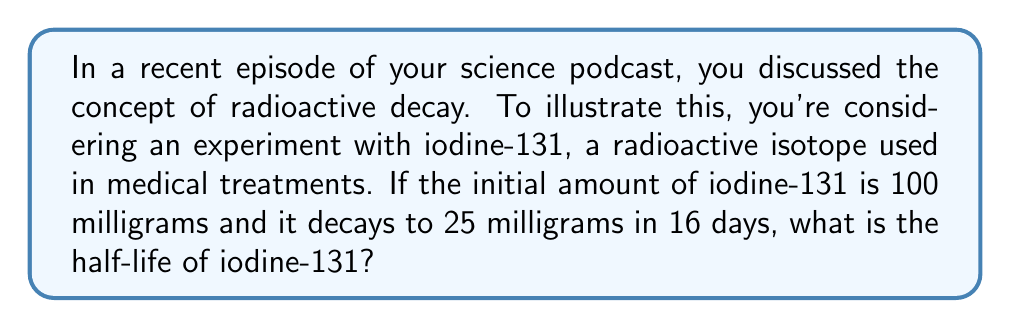Can you answer this question? Let's approach this step-by-step using the exponential decay formula:

1) The general form of the exponential decay equation is:
   $$ A(t) = A_0 e^{-\lambda t} $$
   where $A(t)$ is the amount at time $t$, $A_0$ is the initial amount, $\lambda$ is the decay constant, and $t$ is time.

2) We know:
   $A_0 = 100$ mg
   $A(16) = 25$ mg
   $t = 16$ days

3) Substituting these values into the equation:
   $$ 25 = 100 e^{-16\lambda} $$

4) Dividing both sides by 100:
   $$ 0.25 = e^{-16\lambda} $$

5) Taking the natural log of both sides:
   $$ \ln(0.25) = -16\lambda $$

6) Solving for $\lambda$:
   $$ \lambda = -\frac{\ln(0.25)}{16} \approx 0.0866 \text{ day}^{-1} $$

7) The half-life $t_{1/2}$ is related to $\lambda$ by:
   $$ t_{1/2} = \frac{\ln(2)}{\lambda} $$

8) Substituting our value for $\lambda$:
   $$ t_{1/2} = \frac{\ln(2)}{0.0866} \approx 8 \text{ days} $$

Therefore, the half-life of iodine-131 is approximately 8 days.
Answer: 8 days 